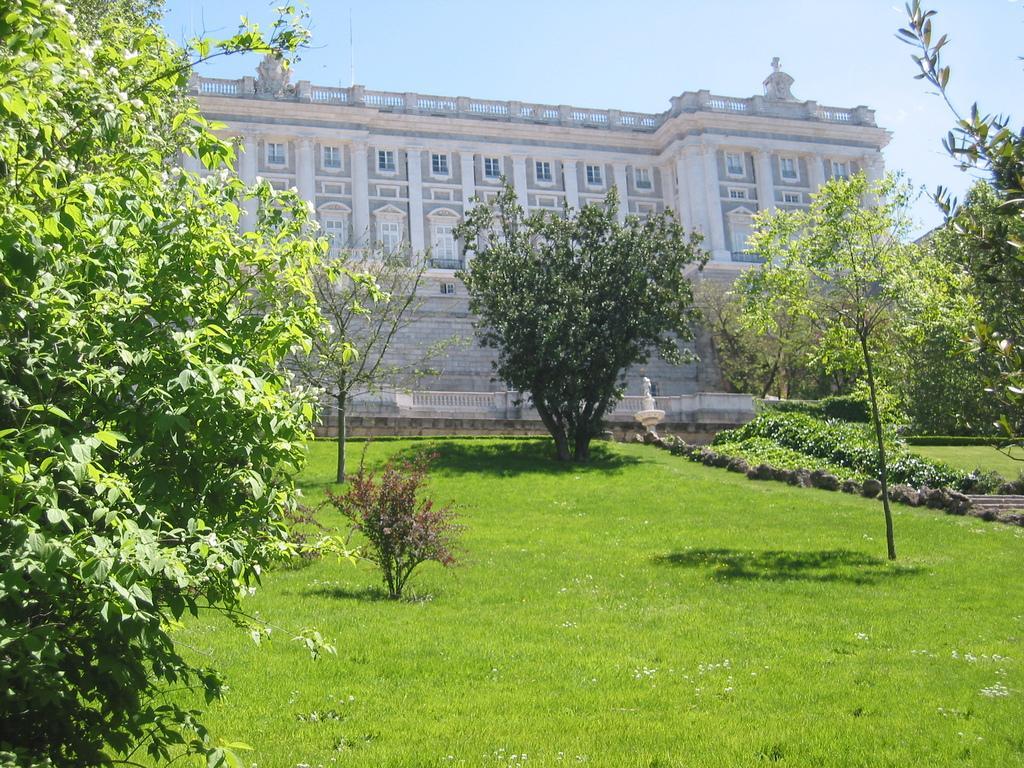Can you describe this image briefly? In this image, we can see the ground covered with grass. There are a few plants and trees. We can see a white colored object. We can see a building. We can see some stairs and the sky. 